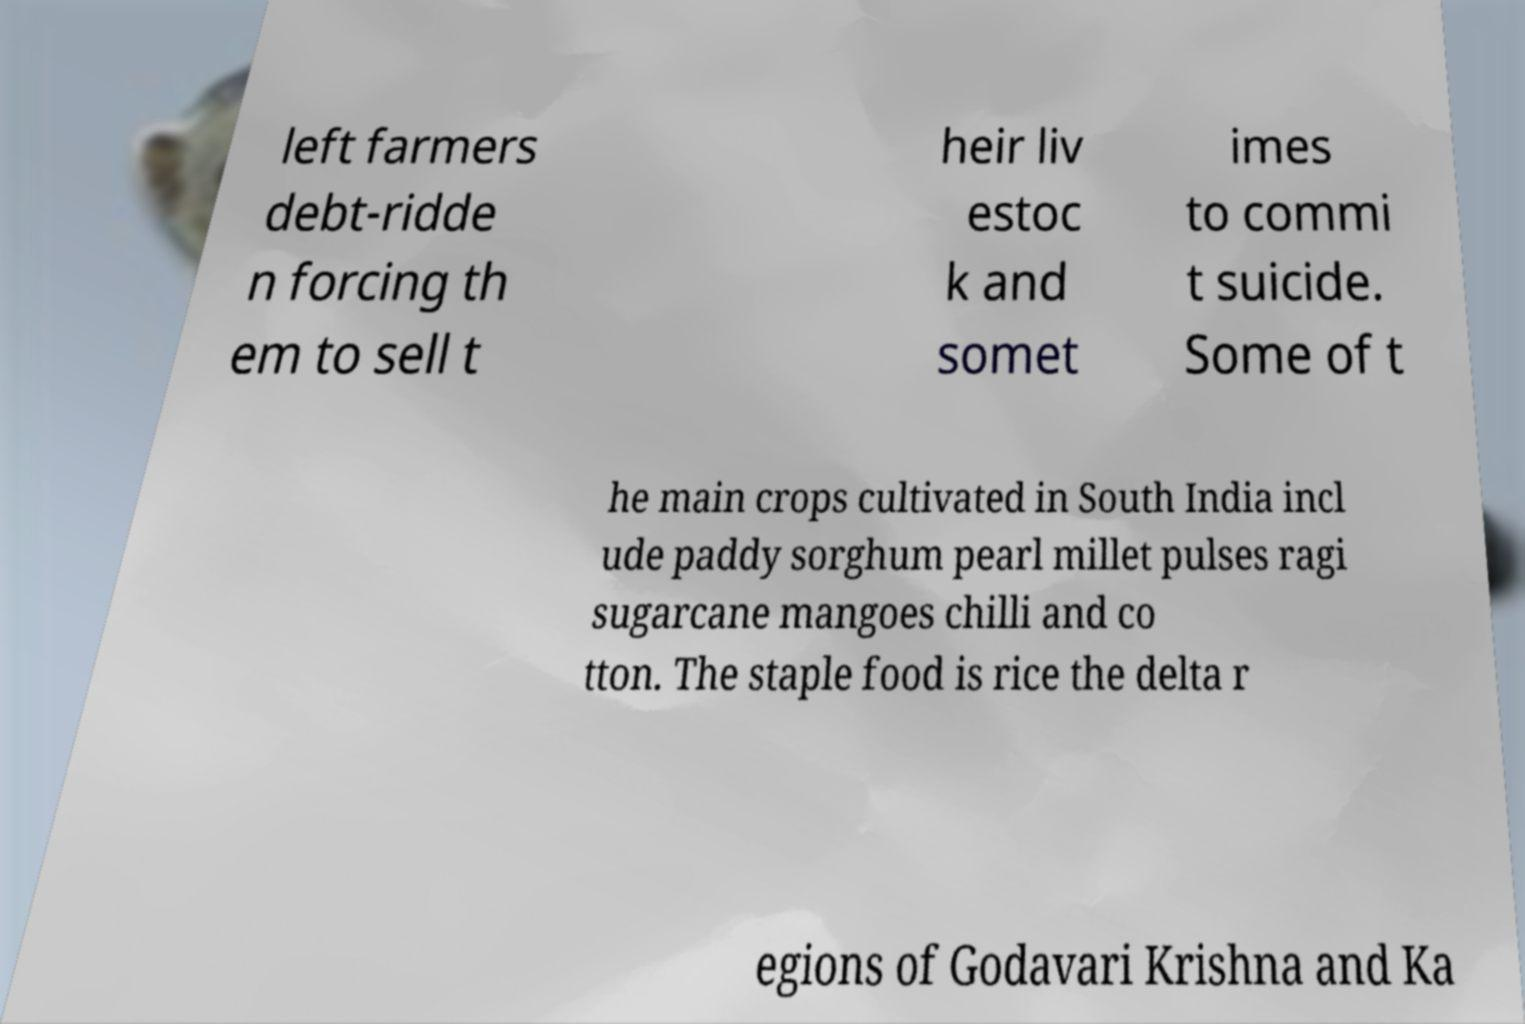I need the written content from this picture converted into text. Can you do that? left farmers debt-ridde n forcing th em to sell t heir liv estoc k and somet imes to commi t suicide. Some of t he main crops cultivated in South India incl ude paddy sorghum pearl millet pulses ragi sugarcane mangoes chilli and co tton. The staple food is rice the delta r egions of Godavari Krishna and Ka 